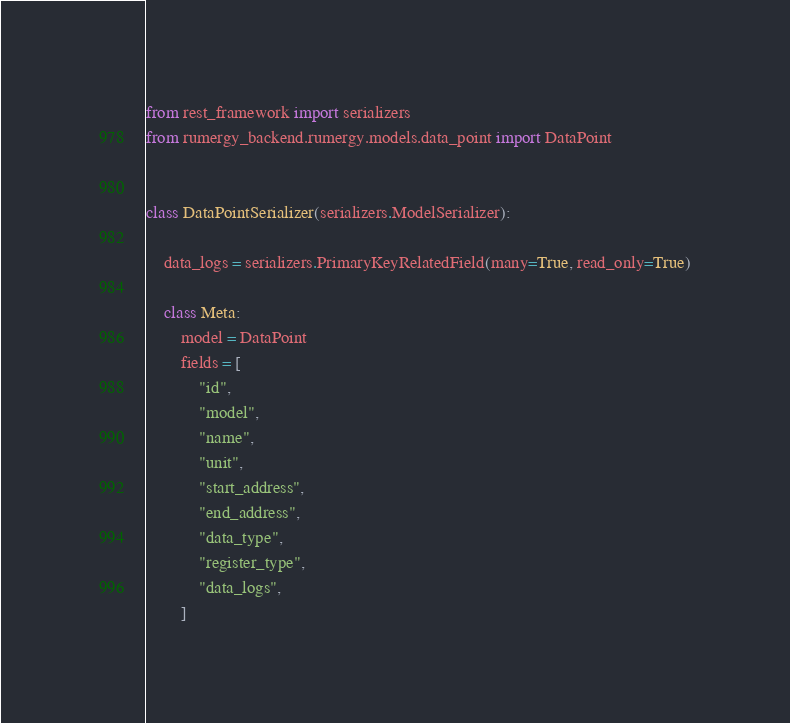<code> <loc_0><loc_0><loc_500><loc_500><_Python_>from rest_framework import serializers
from rumergy_backend.rumergy.models.data_point import DataPoint


class DataPointSerializer(serializers.ModelSerializer):

    data_logs = serializers.PrimaryKeyRelatedField(many=True, read_only=True)

    class Meta:
        model = DataPoint
        fields = [
            "id",
            "model",
            "name",
            "unit",
            "start_address",
            "end_address",
            "data_type",
            "register_type",
            "data_logs",
        ]

</code> 